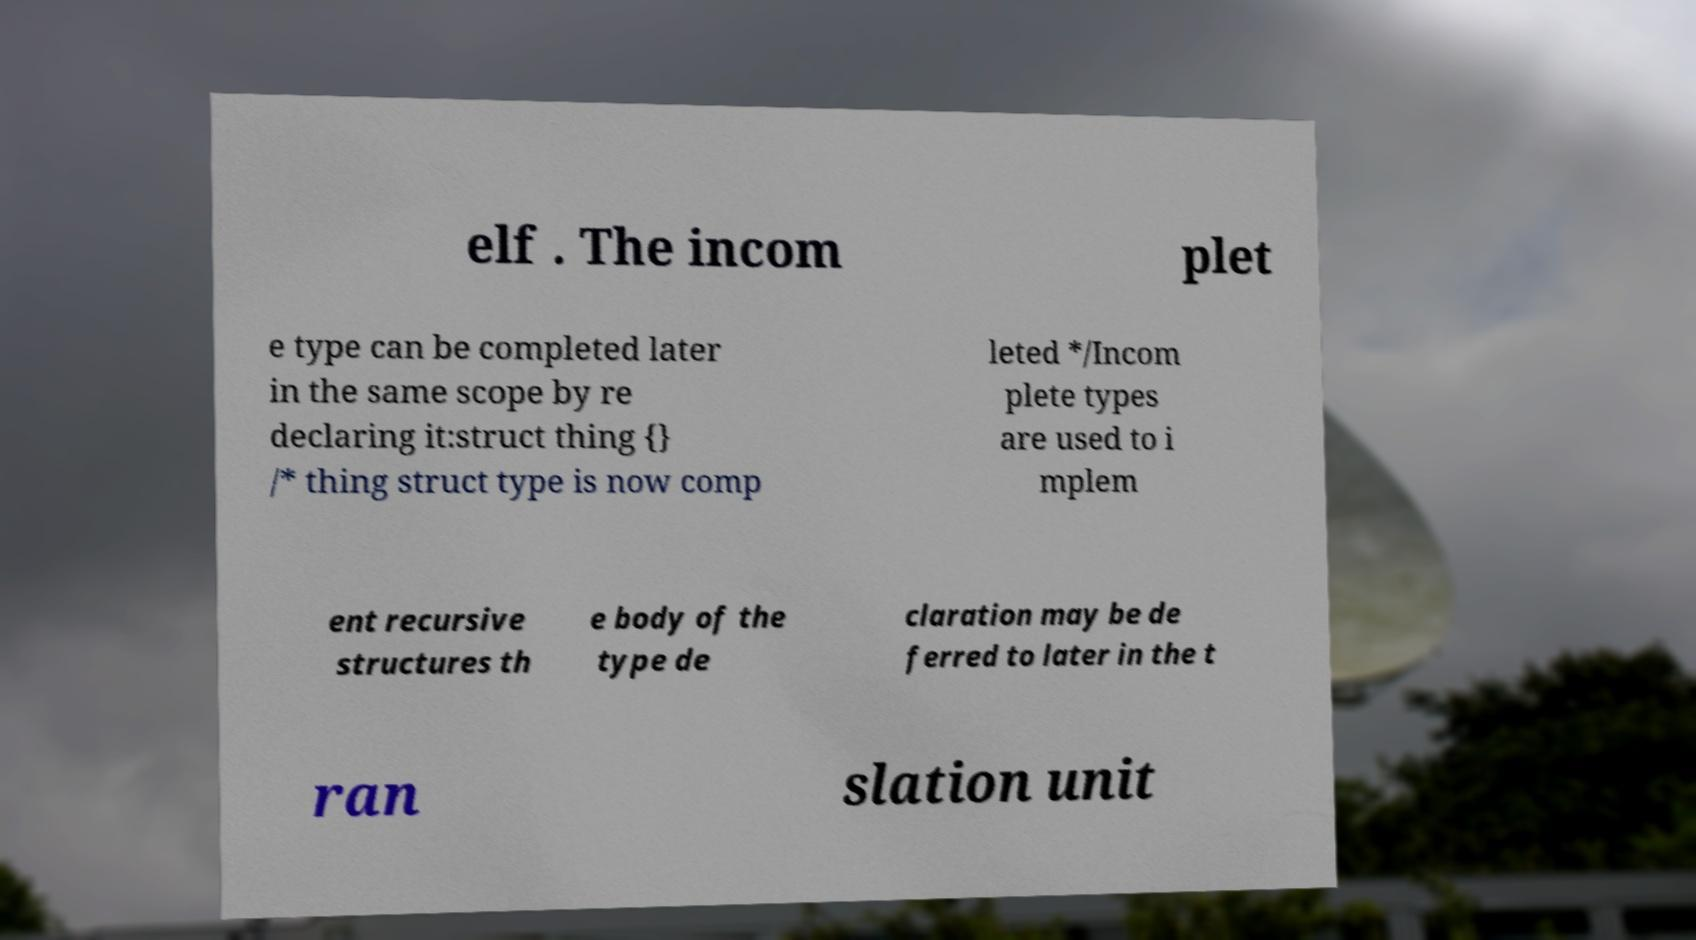Can you read and provide the text displayed in the image?This photo seems to have some interesting text. Can you extract and type it out for me? elf . The incom plet e type can be completed later in the same scope by re declaring it:struct thing {} /* thing struct type is now comp leted */Incom plete types are used to i mplem ent recursive structures th e body of the type de claration may be de ferred to later in the t ran slation unit 